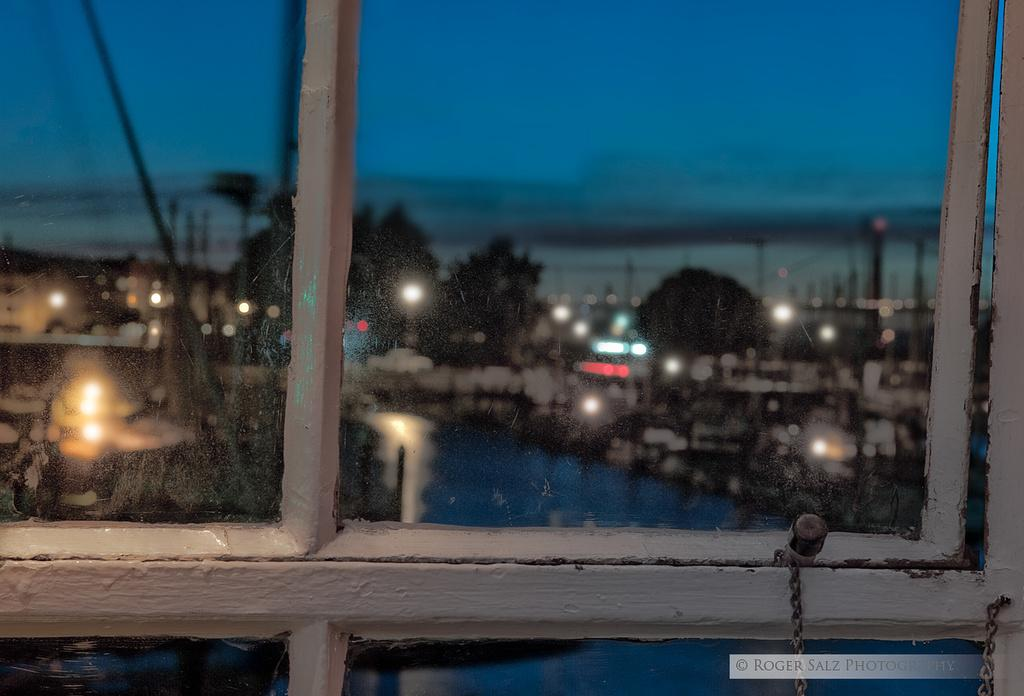What is present in the image that allows for a view of the outside? There is a window in the image. What can be seen through the window? Trees, buildings, a river, lights, and the sky are visible through the window. Can you describe the view through the window? The view includes trees, buildings, a river, lights, and the sky. What type of chair is visible in the image? There is no chair present in the image; it only shows a window with a view of the outside. 